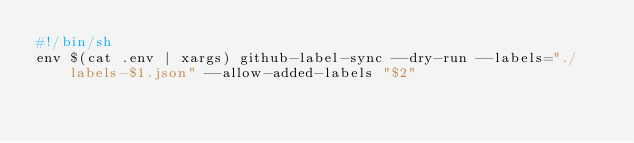<code> <loc_0><loc_0><loc_500><loc_500><_Bash_>#!/bin/sh
env $(cat .env | xargs) github-label-sync --dry-run --labels="./labels-$1.json" --allow-added-labels "$2"

</code> 